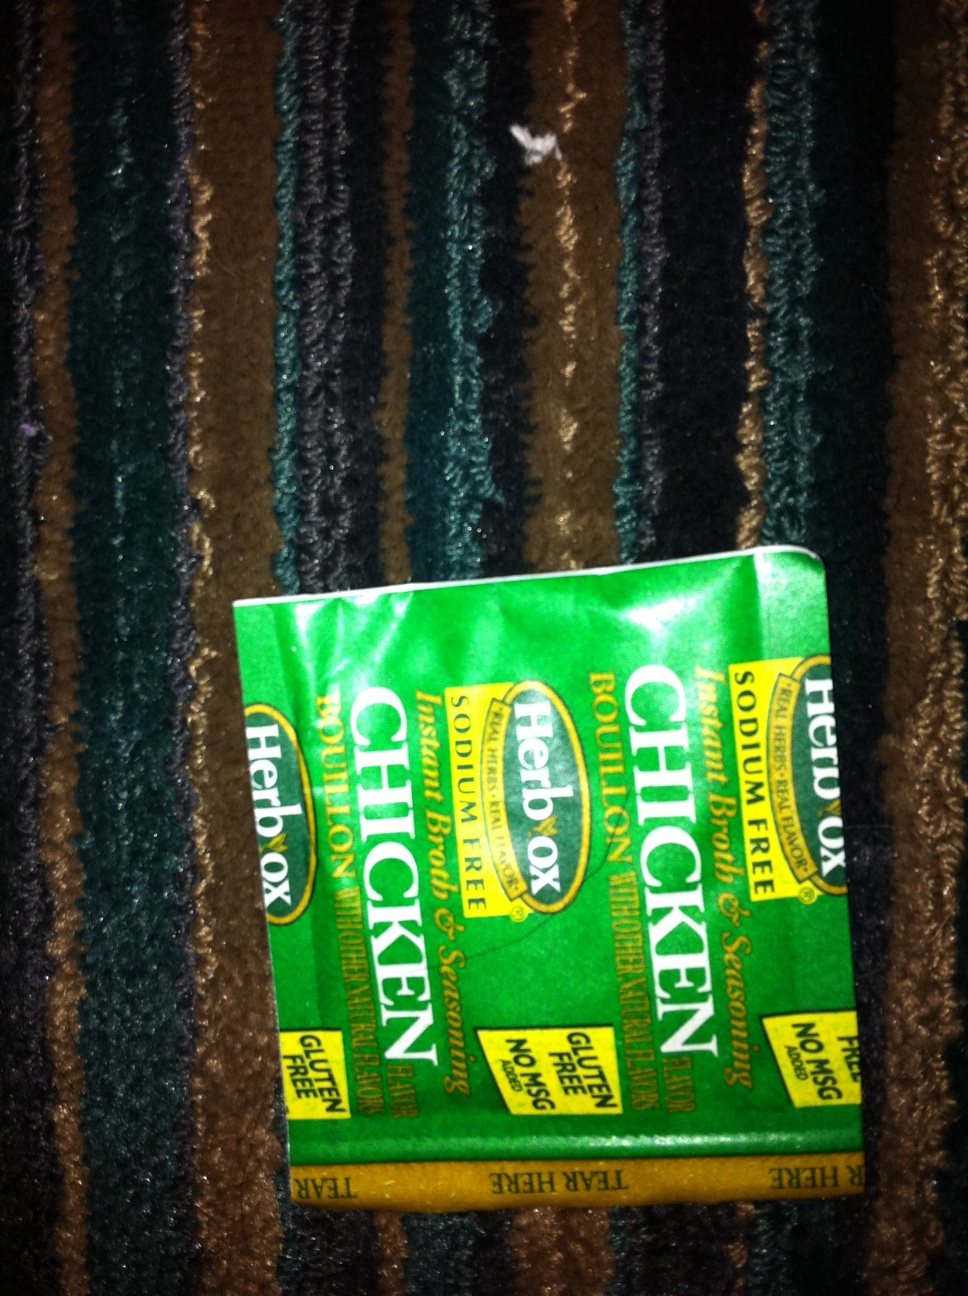Imagine you are a character in a mystery novel involving this bouillon. Describe the plot. In the quaint town of Mystville, famed for its culinary delights, a secret recipe for the world's most comforting chicken soup had been passed down for generations. This recipe, however, was more than just a family heirloom; it held the key to an ancient treasure hidden by Clara's great-great-grandfather, a legendary chef and adventurer.

One fateful night, the town's beloved Herbox Chicken Bouillon's entire stock mysteriously disappeared from the store shelves, leaving everyone puzzled and without their go-to ingredient. Detective Elsie, an astute and curious investigator with a knack for solving culinary crimes, was called to crack the case.

As she delved deeper, she discovered cryptic clues embossed on the bouillon packets. Each packet revealed a fragment of a map leading to the long-lost treasure. The plot thickened when a rival chef, envious of Clara's family's legacy, emerged as a prime suspect. But Elsie’s sharp intuition and a series of clever deductions unveiled a deeper, more sinister conspiracy involving secret societies and forgotten recipes.

In a thrilling chase through Mystville’s historic kitchens and underground tunnels, Detective Elsie uncovered the true mastermind behind the theft. The final showdown, set in the old Mystville Manor, led to the revelation of the treasure—a collection of priceless culinary artifacts and the original, unaltered recipe for the bouillon that had the power to bring people together.

Mystville celebrated Detective Elsie's victory, honoring her with a grand feast where the famous chicken soup, made with the reclaimed Herbox Chicken Bouillon, was the star. The culinary world was restored to its harmonious balance, thanks to the relentless efforts of the detective and a small, humble packet of bouillon. 